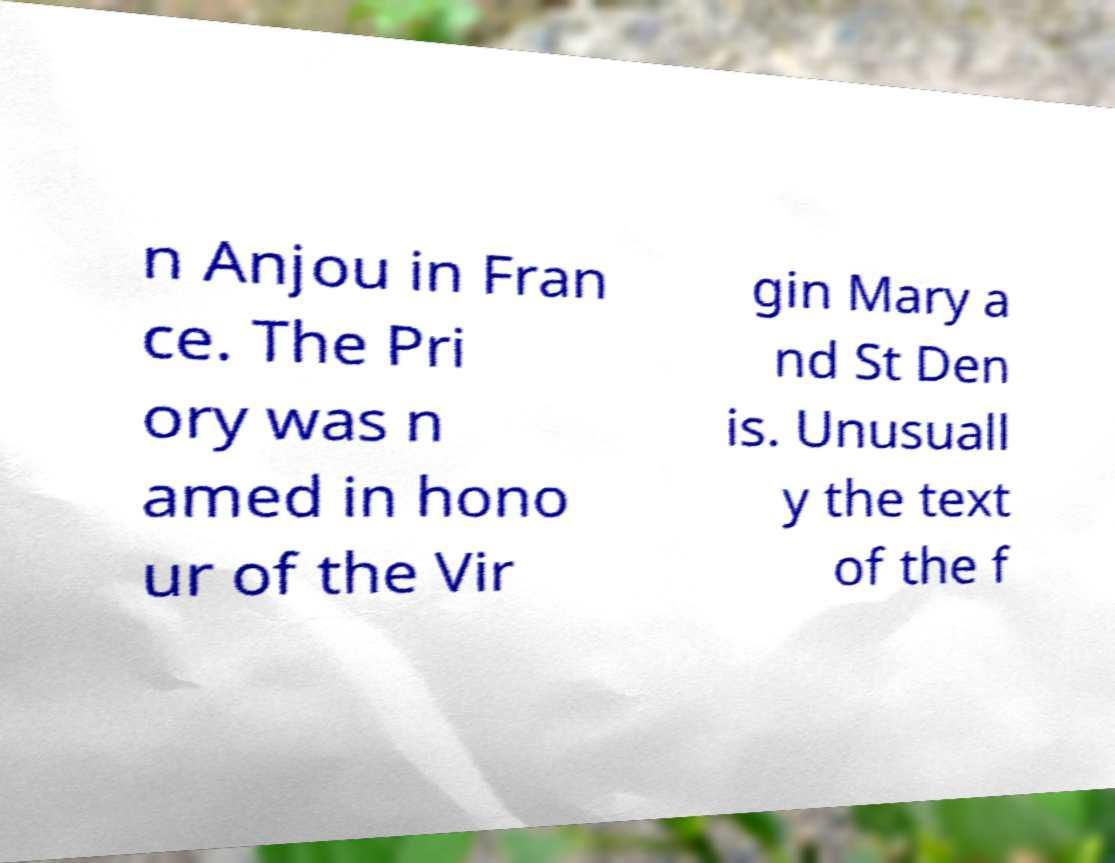Could you assist in decoding the text presented in this image and type it out clearly? n Anjou in Fran ce. The Pri ory was n amed in hono ur of the Vir gin Mary a nd St Den is. Unusuall y the text of the f 